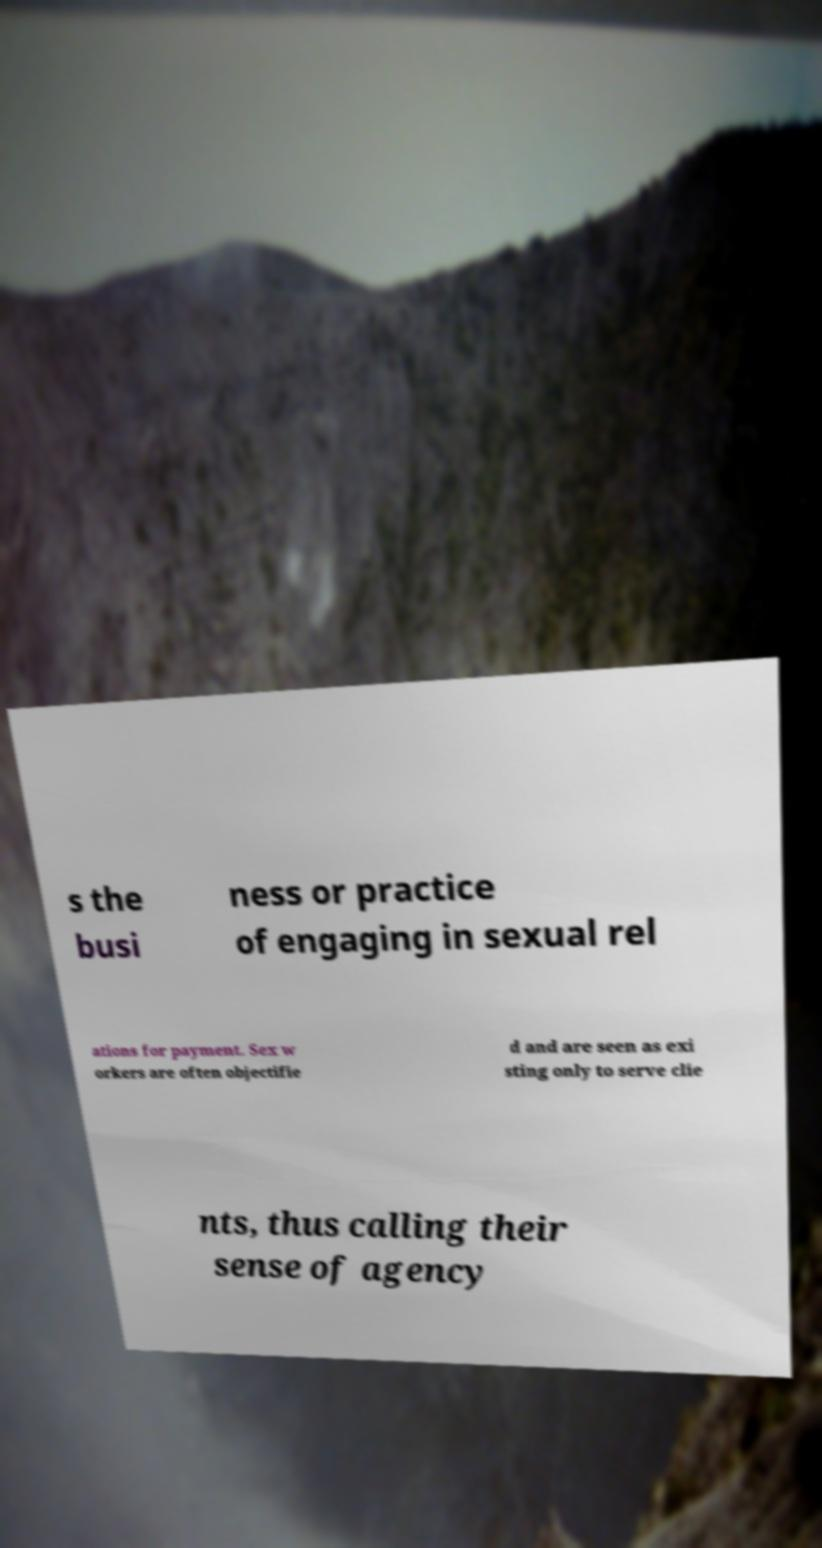Could you extract and type out the text from this image? s the busi ness or practice of engaging in sexual rel ations for payment. Sex w orkers are often objectifie d and are seen as exi sting only to serve clie nts, thus calling their sense of agency 